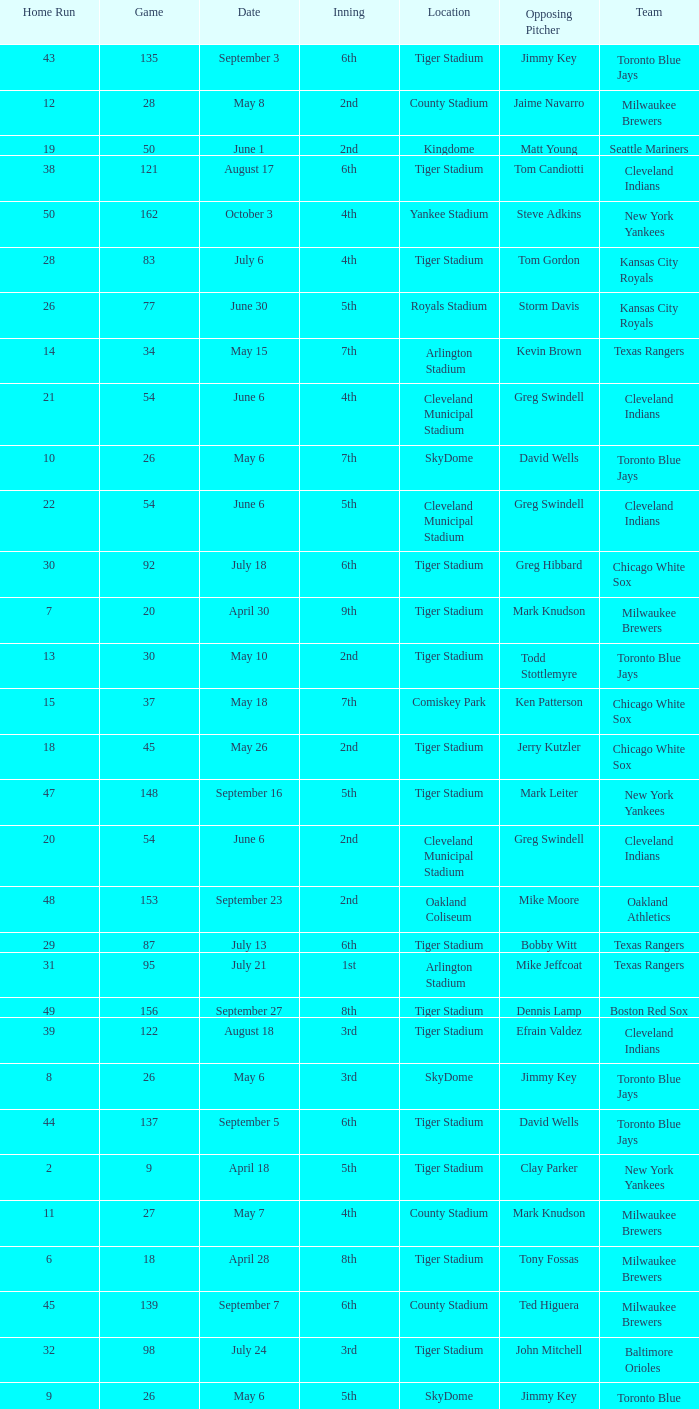What date was the game at Comiskey Park and had a 4th Inning? May 20. 